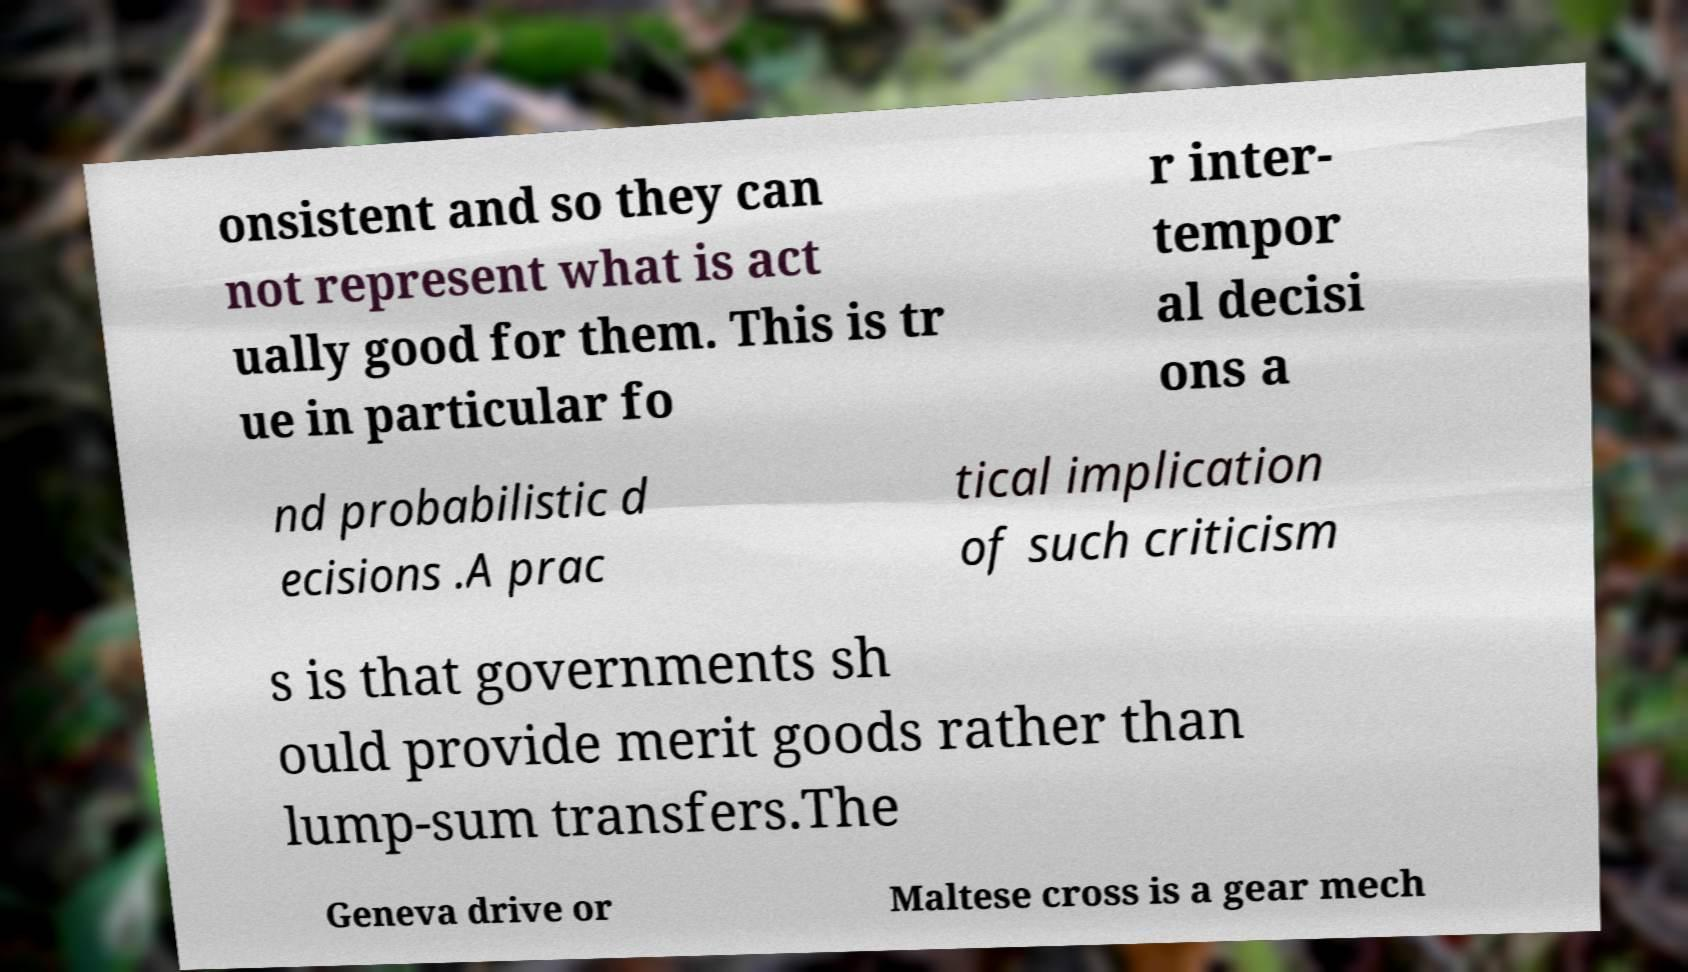Please read and relay the text visible in this image. What does it say? onsistent and so they can not represent what is act ually good for them. This is tr ue in particular fo r inter- tempor al decisi ons a nd probabilistic d ecisions .A prac tical implication of such criticism s is that governments sh ould provide merit goods rather than lump-sum transfers.The Geneva drive or Maltese cross is a gear mech 